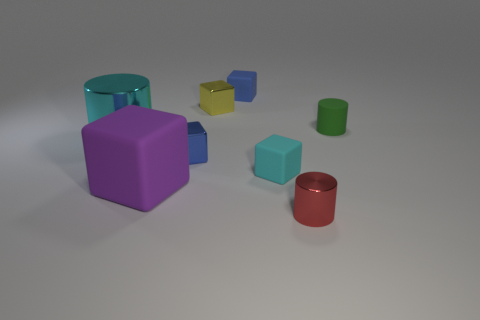Add 2 small metal things. How many objects exist? 10 Subtract all large purple matte cubes. How many cubes are left? 4 Subtract all cubes. How many objects are left? 3 Subtract all cyan blocks. How many blocks are left? 4 Subtract all green spheres. How many cyan cubes are left? 1 Subtract all big cyan things. Subtract all purple blocks. How many objects are left? 6 Add 5 big cubes. How many big cubes are left? 6 Add 8 purple rubber things. How many purple rubber things exist? 9 Subtract 1 green cylinders. How many objects are left? 7 Subtract 1 cylinders. How many cylinders are left? 2 